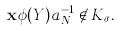Convert formula to latex. <formula><loc_0><loc_0><loc_500><loc_500>\mathbf x \phi ( Y ) a _ { N } ^ { - 1 } \not \in K _ { \sigma } .</formula> 